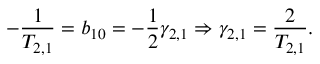Convert formula to latex. <formula><loc_0><loc_0><loc_500><loc_500>- \frac { 1 } { T _ { 2 , 1 } } = b _ { 1 0 } = - \frac { 1 } { 2 } \gamma _ { 2 , 1 } \Rightarrow \gamma _ { 2 , 1 } = \frac { 2 } { T _ { 2 , 1 } } .</formula> 